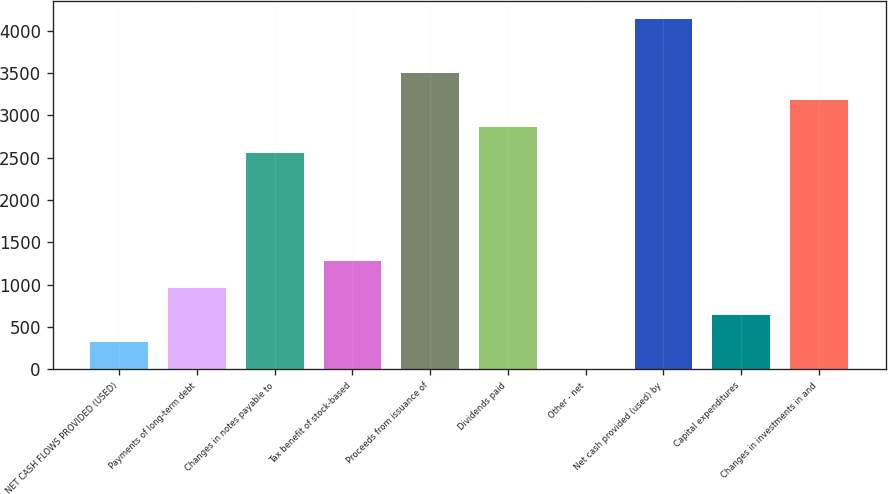Convert chart. <chart><loc_0><loc_0><loc_500><loc_500><bar_chart><fcel>NET CASH FLOWS PROVIDED (USED)<fcel>Payments of long-term debt<fcel>Changes in notes payable to<fcel>Tax benefit of stock-based<fcel>Proceeds from issuance of<fcel>Dividends paid<fcel>Other - net<fcel>Net cash provided (used) by<fcel>Capital expenditures<fcel>Changes in investments in and<nl><fcel>324.8<fcel>960.4<fcel>2549.4<fcel>1278.2<fcel>3502.8<fcel>2867.2<fcel>7<fcel>4138.4<fcel>642.6<fcel>3185<nl></chart> 